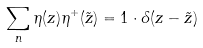Convert formula to latex. <formula><loc_0><loc_0><loc_500><loc_500>\sum _ { n } { \eta ( z ) \eta ^ { + } ( \tilde { z } ) } = { 1 } \cdot \delta ( z - \tilde { z } )</formula> 